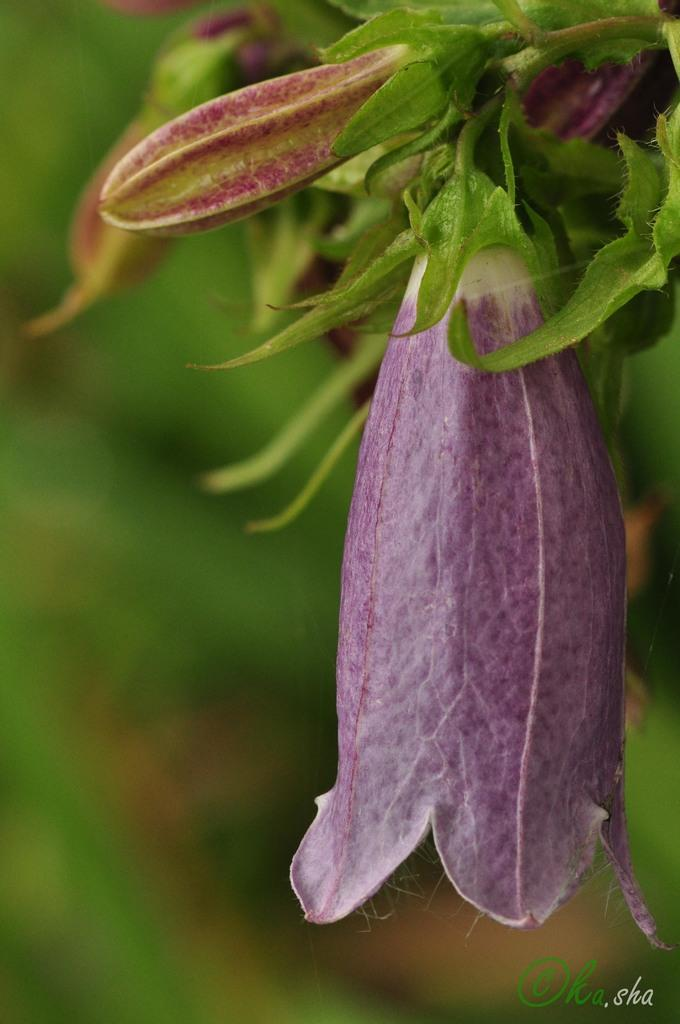What type of flowers can be seen in the image? There are purple color flowers in the image. What else is present in the image besides the flowers? There are leaves in the image. Is there any text or marking in the image? Yes, a watermark is present in the bottom right corner of the image. How many trees are visible in the image? There are no trees visible in the image; it features flowers and leaves. What type of yarn is being used to create the flowers in the image? The image does not depict yarn or any yarn-based creation; it is a photograph of real flowers. 